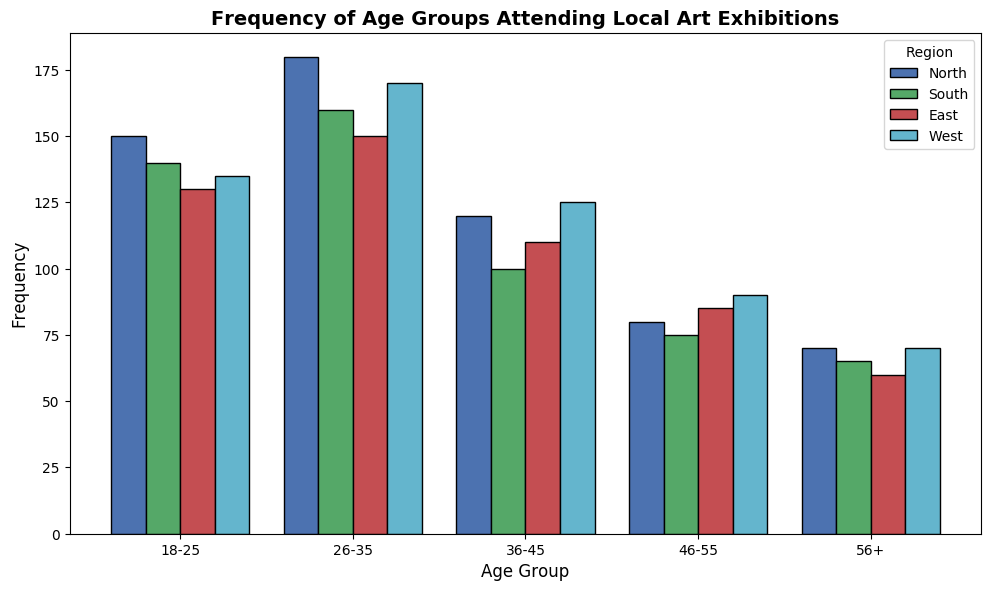Which age group has the highest frequency in the North region? Look for the tallest bar in the North region (blue color) and identify the corresponding age group.
Answer: 26-35 Among the regions, which one has the lowest frequency for the age group 56+? Compare the height of the bars for the age group 56+ across all regions.
Answer: East What is the average frequency of the 18-25 age group across all regions? Sum the frequencies of the 18-25 age group for all regions: 150 (North) + 140 (South) + 130 (East) + 135 (West) = 555. Then, divide by the number of regions (4).
Answer: 138.75 Which region shows the largest difference in frequency between the 26-35 and 36-45 age groups? Calculate the difference in frequencies for each region: North (180-120=60), South (160-100=60), East (150-110=40), West (170-125=45).
Answer: North and South (tie) How does the frequency of the 46-55 age group compare between the South and West regions? Look at the heights of the bars for the 46-55 age group in the South (green) and West (cyan) regions.
Answer: The South region has a lower frequency What is the total frequency of the 36-45 age group across all regions? Add up the frequencies for the 36-45 age group for each region: 120 (North) + 100 (South) + 110 (East) + 125 (West) = 455.
Answer: 455 Which age group has the smallest frequency in the East region? Find the shortest bar in the East region (red color) and identify the age group.
Answer: 56+ In the West region, by how much does the frequency of the 26-35 age group exceed that of the 56+ age group? Subtract the frequency of the 56+ age group from the 26-35 age group in the West region: 170 - 70 = 100.
Answer: 100 What is the frequency difference between the youngest (18-25) and oldest (56+) age groups in the South region? Subtract the frequency of the 56+ age group from the 18-25 age group in the South region: 140 - 65 = 75.
Answer: 75 